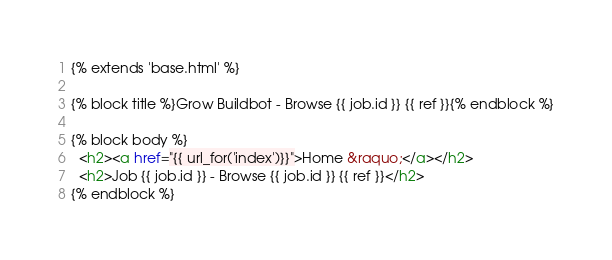Convert code to text. <code><loc_0><loc_0><loc_500><loc_500><_HTML_>{% extends 'base.html' %}

{% block title %}Grow Buildbot - Browse {{ job.id }} {{ ref }}{% endblock %}

{% block body %}
  <h2><a href="{{ url_for('index')}}">Home &raquo;</a></h2>
  <h2>Job {{ job.id }} - Browse {{ job.id }} {{ ref }}</h2>
{% endblock %}
</code> 